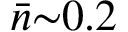Convert formula to latex. <formula><loc_0><loc_0><loc_500><loc_500>\bar { n } { \sim } 0 . 2</formula> 